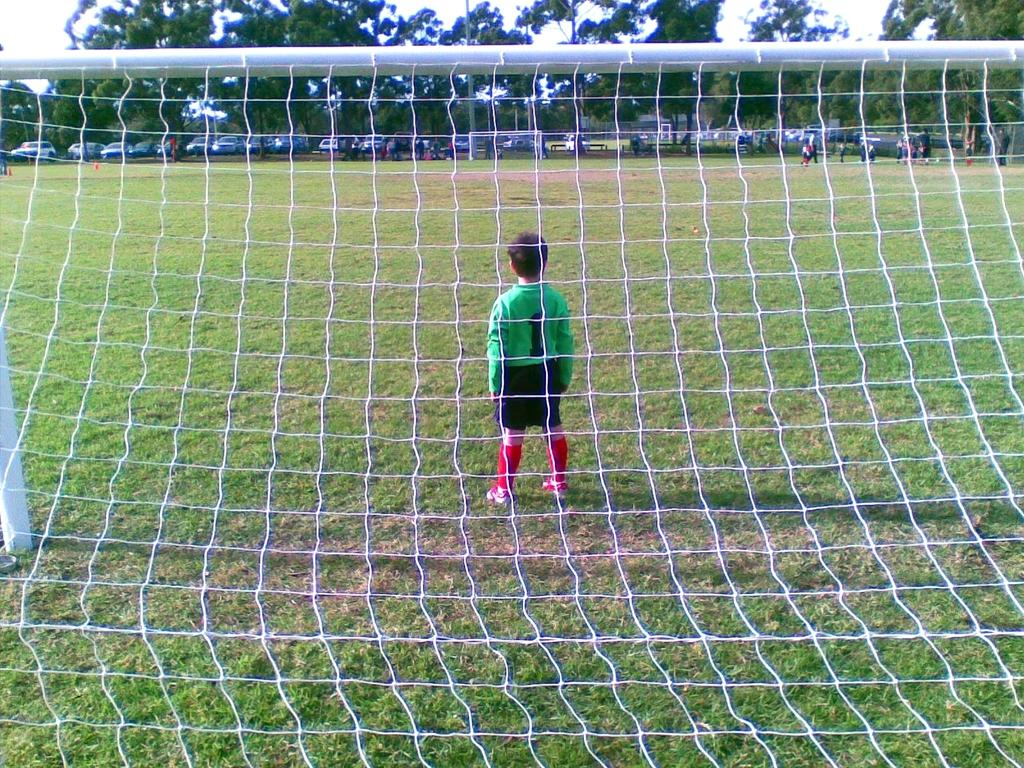What is the main object in the image that has a net and a rod? There is a net with a rod in the image. Where is the net positioned? The net is positioned over grass. What can be seen in the foreground of the image? There is a kid standing in the image. What is visible in the background of the image? In the background, there are people visible, vehicles present, trees visible, and the sky is visible. What type of flight is the kid taking in the image? There is no flight present in the image; it features a kid standing near a net with a rod over grass. What system is the kid using to improve their afterthoughts in the image? There is no mention of a system or afterthoughts in the image; it simply shows a kid standing near a net with a rod over grass. 